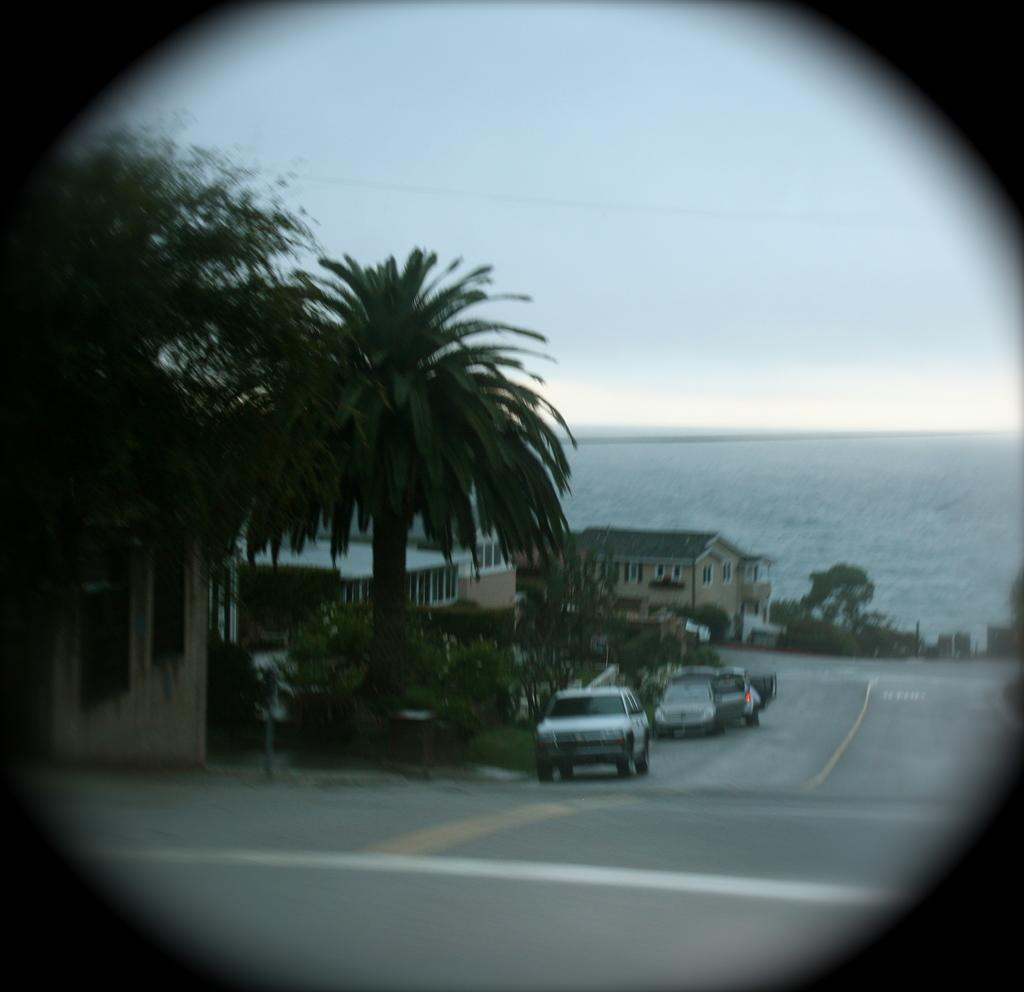What is the main feature of the image? There is a road in the image. What else can be seen near the road? There are vehicles on the side of the road. What type of natural elements are present in the image? There are trees in the image. What type of structures can be seen in the image? There are buildings with windows in the image. What can be seen in the distance in the image? There is water visible in the background, and the sky is also visible in the background. Where is the girl holding the quince in the image? There is no girl holding a quince in the image. 